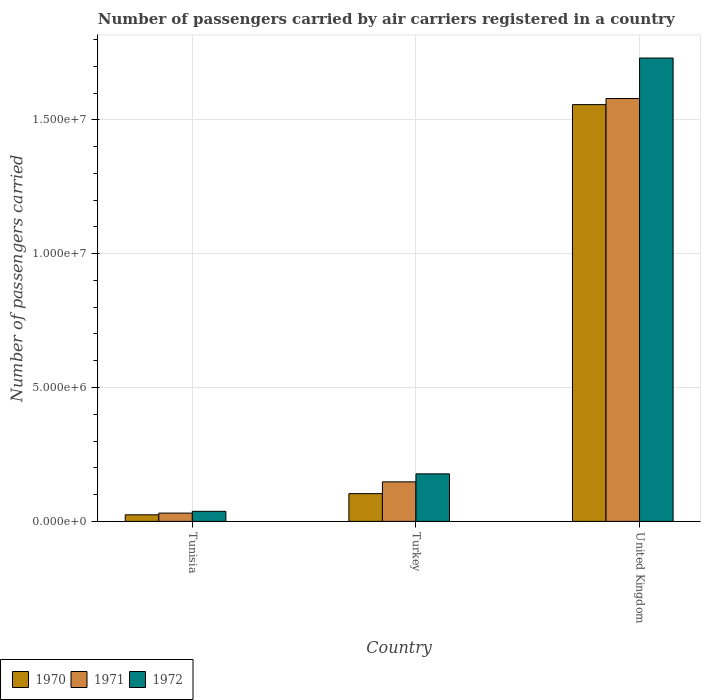How many different coloured bars are there?
Offer a very short reply. 3. Are the number of bars on each tick of the X-axis equal?
Your response must be concise. Yes. How many bars are there on the 3rd tick from the left?
Offer a terse response. 3. What is the number of passengers carried by air carriers in 1972 in Tunisia?
Ensure brevity in your answer.  3.75e+05. Across all countries, what is the maximum number of passengers carried by air carriers in 1971?
Offer a terse response. 1.58e+07. Across all countries, what is the minimum number of passengers carried by air carriers in 1971?
Provide a succinct answer. 3.09e+05. In which country was the number of passengers carried by air carriers in 1970 maximum?
Make the answer very short. United Kingdom. In which country was the number of passengers carried by air carriers in 1971 minimum?
Make the answer very short. Tunisia. What is the total number of passengers carried by air carriers in 1972 in the graph?
Your answer should be very brief. 1.95e+07. What is the difference between the number of passengers carried by air carriers in 1972 in Tunisia and that in Turkey?
Ensure brevity in your answer.  -1.40e+06. What is the difference between the number of passengers carried by air carriers in 1970 in Tunisia and the number of passengers carried by air carriers in 1972 in Turkey?
Give a very brief answer. -1.53e+06. What is the average number of passengers carried by air carriers in 1970 per country?
Your answer should be compact. 5.62e+06. What is the difference between the number of passengers carried by air carriers of/in 1970 and number of passengers carried by air carriers of/in 1971 in Turkey?
Make the answer very short. -4.40e+05. What is the ratio of the number of passengers carried by air carriers in 1971 in Tunisia to that in United Kingdom?
Ensure brevity in your answer.  0.02. Is the number of passengers carried by air carriers in 1971 in Tunisia less than that in United Kingdom?
Your answer should be compact. Yes. What is the difference between the highest and the second highest number of passengers carried by air carriers in 1972?
Offer a very short reply. -1.55e+07. What is the difference between the highest and the lowest number of passengers carried by air carriers in 1970?
Your answer should be compact. 1.53e+07. What does the 1st bar from the left in Turkey represents?
Offer a terse response. 1970. Is it the case that in every country, the sum of the number of passengers carried by air carriers in 1970 and number of passengers carried by air carriers in 1971 is greater than the number of passengers carried by air carriers in 1972?
Offer a very short reply. Yes. How many countries are there in the graph?
Give a very brief answer. 3. Does the graph contain any zero values?
Make the answer very short. No. Where does the legend appear in the graph?
Your response must be concise. Bottom left. How many legend labels are there?
Offer a very short reply. 3. How are the legend labels stacked?
Offer a very short reply. Horizontal. What is the title of the graph?
Provide a short and direct response. Number of passengers carried by air carriers registered in a country. Does "1961" appear as one of the legend labels in the graph?
Provide a short and direct response. No. What is the label or title of the Y-axis?
Give a very brief answer. Number of passengers carried. What is the Number of passengers carried in 1970 in Tunisia?
Your answer should be compact. 2.45e+05. What is the Number of passengers carried in 1971 in Tunisia?
Your response must be concise. 3.09e+05. What is the Number of passengers carried in 1972 in Tunisia?
Your answer should be very brief. 3.75e+05. What is the Number of passengers carried of 1970 in Turkey?
Your response must be concise. 1.04e+06. What is the Number of passengers carried in 1971 in Turkey?
Provide a short and direct response. 1.48e+06. What is the Number of passengers carried of 1972 in Turkey?
Offer a very short reply. 1.77e+06. What is the Number of passengers carried in 1970 in United Kingdom?
Give a very brief answer. 1.56e+07. What is the Number of passengers carried in 1971 in United Kingdom?
Your answer should be very brief. 1.58e+07. What is the Number of passengers carried of 1972 in United Kingdom?
Provide a short and direct response. 1.73e+07. Across all countries, what is the maximum Number of passengers carried of 1970?
Offer a terse response. 1.56e+07. Across all countries, what is the maximum Number of passengers carried in 1971?
Provide a short and direct response. 1.58e+07. Across all countries, what is the maximum Number of passengers carried of 1972?
Provide a short and direct response. 1.73e+07. Across all countries, what is the minimum Number of passengers carried of 1970?
Ensure brevity in your answer.  2.45e+05. Across all countries, what is the minimum Number of passengers carried of 1971?
Provide a succinct answer. 3.09e+05. Across all countries, what is the minimum Number of passengers carried in 1972?
Provide a short and direct response. 3.75e+05. What is the total Number of passengers carried of 1970 in the graph?
Keep it short and to the point. 1.68e+07. What is the total Number of passengers carried in 1971 in the graph?
Give a very brief answer. 1.76e+07. What is the total Number of passengers carried in 1972 in the graph?
Your response must be concise. 1.95e+07. What is the difference between the Number of passengers carried in 1970 in Tunisia and that in Turkey?
Make the answer very short. -7.91e+05. What is the difference between the Number of passengers carried of 1971 in Tunisia and that in Turkey?
Offer a very short reply. -1.17e+06. What is the difference between the Number of passengers carried of 1972 in Tunisia and that in Turkey?
Your response must be concise. -1.40e+06. What is the difference between the Number of passengers carried of 1970 in Tunisia and that in United Kingdom?
Keep it short and to the point. -1.53e+07. What is the difference between the Number of passengers carried of 1971 in Tunisia and that in United Kingdom?
Your answer should be very brief. -1.55e+07. What is the difference between the Number of passengers carried of 1972 in Tunisia and that in United Kingdom?
Your response must be concise. -1.69e+07. What is the difference between the Number of passengers carried of 1970 in Turkey and that in United Kingdom?
Your answer should be very brief. -1.45e+07. What is the difference between the Number of passengers carried in 1971 in Turkey and that in United Kingdom?
Keep it short and to the point. -1.43e+07. What is the difference between the Number of passengers carried of 1972 in Turkey and that in United Kingdom?
Ensure brevity in your answer.  -1.55e+07. What is the difference between the Number of passengers carried in 1970 in Tunisia and the Number of passengers carried in 1971 in Turkey?
Your response must be concise. -1.23e+06. What is the difference between the Number of passengers carried in 1970 in Tunisia and the Number of passengers carried in 1972 in Turkey?
Your answer should be compact. -1.53e+06. What is the difference between the Number of passengers carried in 1971 in Tunisia and the Number of passengers carried in 1972 in Turkey?
Ensure brevity in your answer.  -1.47e+06. What is the difference between the Number of passengers carried in 1970 in Tunisia and the Number of passengers carried in 1971 in United Kingdom?
Ensure brevity in your answer.  -1.56e+07. What is the difference between the Number of passengers carried in 1970 in Tunisia and the Number of passengers carried in 1972 in United Kingdom?
Give a very brief answer. -1.71e+07. What is the difference between the Number of passengers carried of 1971 in Tunisia and the Number of passengers carried of 1972 in United Kingdom?
Offer a very short reply. -1.70e+07. What is the difference between the Number of passengers carried of 1970 in Turkey and the Number of passengers carried of 1971 in United Kingdom?
Provide a succinct answer. -1.48e+07. What is the difference between the Number of passengers carried in 1970 in Turkey and the Number of passengers carried in 1972 in United Kingdom?
Provide a short and direct response. -1.63e+07. What is the difference between the Number of passengers carried of 1971 in Turkey and the Number of passengers carried of 1972 in United Kingdom?
Provide a short and direct response. -1.58e+07. What is the average Number of passengers carried in 1970 per country?
Keep it short and to the point. 5.62e+06. What is the average Number of passengers carried in 1971 per country?
Your answer should be very brief. 5.86e+06. What is the average Number of passengers carried in 1972 per country?
Your response must be concise. 6.49e+06. What is the difference between the Number of passengers carried in 1970 and Number of passengers carried in 1971 in Tunisia?
Ensure brevity in your answer.  -6.41e+04. What is the difference between the Number of passengers carried of 1970 and Number of passengers carried of 1972 in Tunisia?
Your answer should be compact. -1.30e+05. What is the difference between the Number of passengers carried in 1971 and Number of passengers carried in 1972 in Tunisia?
Give a very brief answer. -6.62e+04. What is the difference between the Number of passengers carried in 1970 and Number of passengers carried in 1971 in Turkey?
Give a very brief answer. -4.40e+05. What is the difference between the Number of passengers carried of 1970 and Number of passengers carried of 1972 in Turkey?
Ensure brevity in your answer.  -7.39e+05. What is the difference between the Number of passengers carried of 1971 and Number of passengers carried of 1972 in Turkey?
Offer a very short reply. -2.98e+05. What is the difference between the Number of passengers carried of 1970 and Number of passengers carried of 1971 in United Kingdom?
Ensure brevity in your answer.  -2.27e+05. What is the difference between the Number of passengers carried in 1970 and Number of passengers carried in 1972 in United Kingdom?
Provide a short and direct response. -1.74e+06. What is the difference between the Number of passengers carried of 1971 and Number of passengers carried of 1972 in United Kingdom?
Your response must be concise. -1.51e+06. What is the ratio of the Number of passengers carried in 1970 in Tunisia to that in Turkey?
Offer a terse response. 0.24. What is the ratio of the Number of passengers carried in 1971 in Tunisia to that in Turkey?
Give a very brief answer. 0.21. What is the ratio of the Number of passengers carried of 1972 in Tunisia to that in Turkey?
Your answer should be compact. 0.21. What is the ratio of the Number of passengers carried of 1970 in Tunisia to that in United Kingdom?
Give a very brief answer. 0.02. What is the ratio of the Number of passengers carried in 1971 in Tunisia to that in United Kingdom?
Offer a terse response. 0.02. What is the ratio of the Number of passengers carried of 1972 in Tunisia to that in United Kingdom?
Keep it short and to the point. 0.02. What is the ratio of the Number of passengers carried of 1970 in Turkey to that in United Kingdom?
Offer a terse response. 0.07. What is the ratio of the Number of passengers carried of 1971 in Turkey to that in United Kingdom?
Keep it short and to the point. 0.09. What is the ratio of the Number of passengers carried of 1972 in Turkey to that in United Kingdom?
Provide a succinct answer. 0.1. What is the difference between the highest and the second highest Number of passengers carried in 1970?
Keep it short and to the point. 1.45e+07. What is the difference between the highest and the second highest Number of passengers carried of 1971?
Provide a short and direct response. 1.43e+07. What is the difference between the highest and the second highest Number of passengers carried of 1972?
Provide a succinct answer. 1.55e+07. What is the difference between the highest and the lowest Number of passengers carried of 1970?
Offer a very short reply. 1.53e+07. What is the difference between the highest and the lowest Number of passengers carried in 1971?
Your answer should be very brief. 1.55e+07. What is the difference between the highest and the lowest Number of passengers carried of 1972?
Offer a very short reply. 1.69e+07. 